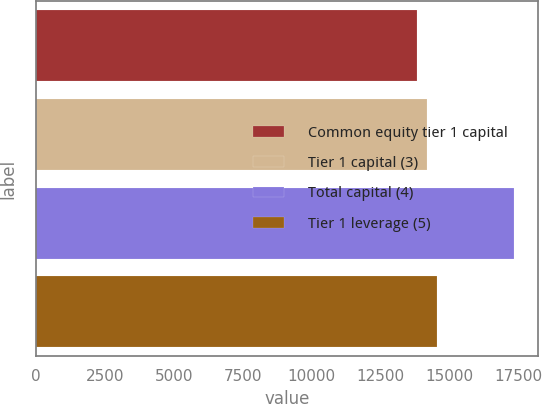Convert chart to OTSL. <chart><loc_0><loc_0><loc_500><loc_500><bar_chart><fcel>Common equity tier 1 capital<fcel>Tier 1 capital (3)<fcel>Total capital (4)<fcel>Tier 1 leverage (5)<nl><fcel>13822<fcel>14174.5<fcel>17347<fcel>14527<nl></chart> 